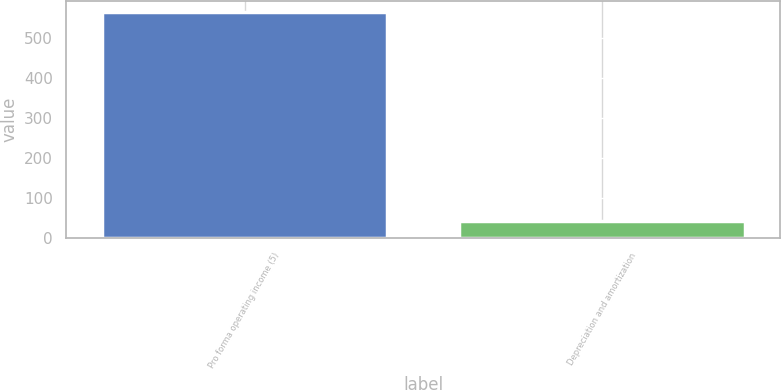Convert chart. <chart><loc_0><loc_0><loc_500><loc_500><bar_chart><fcel>Pro forma operating income (5)<fcel>Depreciation and amortization<nl><fcel>566.5<fcel>42.4<nl></chart> 